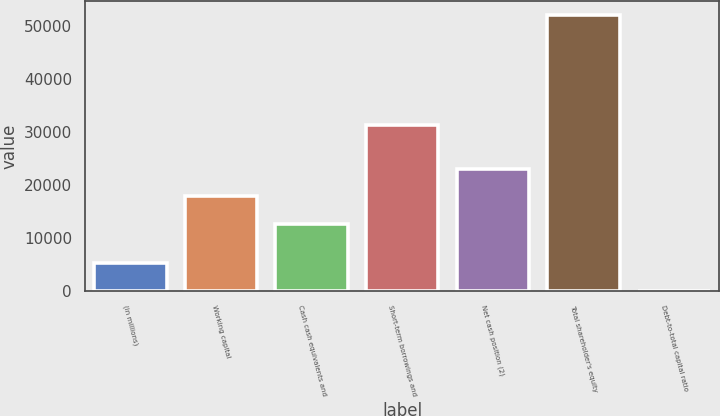<chart> <loc_0><loc_0><loc_500><loc_500><bar_chart><fcel>(in millions)<fcel>Working capital<fcel>Cash cash equivalents and<fcel>Short-term borrowings and<fcel>Net cash position (2)<fcel>Total shareholder's equity<fcel>Debt-to-total capital ratio<nl><fcel>5240.5<fcel>17836.5<fcel>12634<fcel>31240<fcel>23039<fcel>52063<fcel>38<nl></chart> 